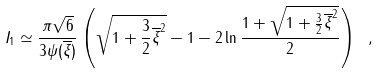<formula> <loc_0><loc_0><loc_500><loc_500>I _ { 1 } \simeq \frac { \pi \sqrt { 6 } } { 3 \psi ( \overline { \xi } ) } \left ( \sqrt { 1 + \frac { 3 } { 2 } \overline { \xi } ^ { 2 } } - 1 - 2 \ln \frac { 1 + \sqrt { 1 + \frac { 3 } { 2 } \overline { \xi } ^ { 2 } } } { 2 } \right ) \ ,</formula> 